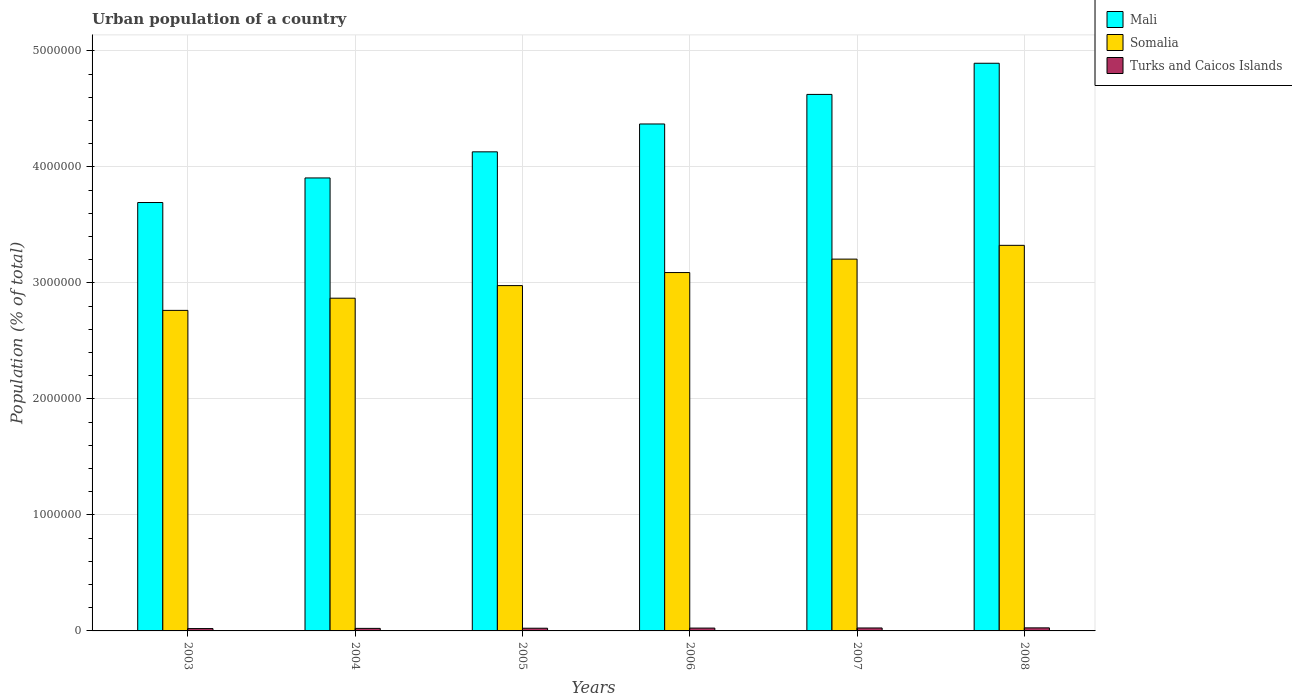How many different coloured bars are there?
Your answer should be very brief. 3. What is the urban population in Mali in 2007?
Offer a very short reply. 4.62e+06. Across all years, what is the maximum urban population in Mali?
Offer a terse response. 4.89e+06. Across all years, what is the minimum urban population in Mali?
Your answer should be very brief. 3.69e+06. In which year was the urban population in Turks and Caicos Islands maximum?
Give a very brief answer. 2008. What is the total urban population in Turks and Caicos Islands in the graph?
Ensure brevity in your answer.  1.41e+05. What is the difference between the urban population in Turks and Caicos Islands in 2003 and that in 2004?
Offer a very short reply. -1542. What is the difference between the urban population in Turks and Caicos Islands in 2003 and the urban population in Mali in 2005?
Your answer should be very brief. -4.11e+06. What is the average urban population in Turks and Caicos Islands per year?
Give a very brief answer. 2.36e+04. In the year 2005, what is the difference between the urban population in Turks and Caicos Islands and urban population in Mali?
Keep it short and to the point. -4.11e+06. In how many years, is the urban population in Turks and Caicos Islands greater than 1800000 %?
Make the answer very short. 0. What is the ratio of the urban population in Turks and Caicos Islands in 2003 to that in 2007?
Your answer should be compact. 0.8. Is the difference between the urban population in Turks and Caicos Islands in 2006 and 2007 greater than the difference between the urban population in Mali in 2006 and 2007?
Ensure brevity in your answer.  Yes. What is the difference between the highest and the second highest urban population in Turks and Caicos Islands?
Make the answer very short. 895. What is the difference between the highest and the lowest urban population in Somalia?
Ensure brevity in your answer.  5.61e+05. In how many years, is the urban population in Somalia greater than the average urban population in Somalia taken over all years?
Offer a terse response. 3. What does the 3rd bar from the left in 2004 represents?
Make the answer very short. Turks and Caicos Islands. What does the 1st bar from the right in 2004 represents?
Provide a succinct answer. Turks and Caicos Islands. Are all the bars in the graph horizontal?
Offer a very short reply. No. What is the difference between two consecutive major ticks on the Y-axis?
Your answer should be very brief. 1.00e+06. Does the graph contain grids?
Your answer should be very brief. Yes. How are the legend labels stacked?
Offer a very short reply. Vertical. What is the title of the graph?
Provide a succinct answer. Urban population of a country. What is the label or title of the X-axis?
Provide a short and direct response. Years. What is the label or title of the Y-axis?
Give a very brief answer. Population (% of total). What is the Population (% of total) of Mali in 2003?
Your answer should be very brief. 3.69e+06. What is the Population (% of total) of Somalia in 2003?
Offer a terse response. 2.76e+06. What is the Population (% of total) of Turks and Caicos Islands in 2003?
Your answer should be compact. 2.03e+04. What is the Population (% of total) in Mali in 2004?
Provide a short and direct response. 3.90e+06. What is the Population (% of total) of Somalia in 2004?
Offer a terse response. 2.87e+06. What is the Population (% of total) of Turks and Caicos Islands in 2004?
Offer a very short reply. 2.18e+04. What is the Population (% of total) in Mali in 2005?
Provide a succinct answer. 4.13e+06. What is the Population (% of total) in Somalia in 2005?
Offer a terse response. 2.98e+06. What is the Population (% of total) in Turks and Caicos Islands in 2005?
Offer a very short reply. 2.32e+04. What is the Population (% of total) of Mali in 2006?
Make the answer very short. 4.37e+06. What is the Population (% of total) in Somalia in 2006?
Offer a very short reply. 3.09e+06. What is the Population (% of total) in Turks and Caicos Islands in 2006?
Your response must be concise. 2.44e+04. What is the Population (% of total) in Mali in 2007?
Offer a terse response. 4.62e+06. What is the Population (% of total) of Somalia in 2007?
Ensure brevity in your answer.  3.20e+06. What is the Population (% of total) of Turks and Caicos Islands in 2007?
Your response must be concise. 2.54e+04. What is the Population (% of total) in Mali in 2008?
Your response must be concise. 4.89e+06. What is the Population (% of total) in Somalia in 2008?
Make the answer very short. 3.32e+06. What is the Population (% of total) of Turks and Caicos Islands in 2008?
Your answer should be very brief. 2.63e+04. Across all years, what is the maximum Population (% of total) of Mali?
Keep it short and to the point. 4.89e+06. Across all years, what is the maximum Population (% of total) in Somalia?
Provide a short and direct response. 3.32e+06. Across all years, what is the maximum Population (% of total) in Turks and Caicos Islands?
Provide a short and direct response. 2.63e+04. Across all years, what is the minimum Population (% of total) of Mali?
Offer a terse response. 3.69e+06. Across all years, what is the minimum Population (% of total) in Somalia?
Give a very brief answer. 2.76e+06. Across all years, what is the minimum Population (% of total) of Turks and Caicos Islands?
Provide a short and direct response. 2.03e+04. What is the total Population (% of total) of Mali in the graph?
Provide a short and direct response. 2.56e+07. What is the total Population (% of total) in Somalia in the graph?
Provide a succinct answer. 1.82e+07. What is the total Population (% of total) in Turks and Caicos Islands in the graph?
Offer a very short reply. 1.41e+05. What is the difference between the Population (% of total) in Mali in 2003 and that in 2004?
Your answer should be very brief. -2.12e+05. What is the difference between the Population (% of total) in Somalia in 2003 and that in 2004?
Make the answer very short. -1.05e+05. What is the difference between the Population (% of total) in Turks and Caicos Islands in 2003 and that in 2004?
Offer a very short reply. -1542. What is the difference between the Population (% of total) of Mali in 2003 and that in 2005?
Make the answer very short. -4.37e+05. What is the difference between the Population (% of total) in Somalia in 2003 and that in 2005?
Ensure brevity in your answer.  -2.14e+05. What is the difference between the Population (% of total) in Turks and Caicos Islands in 2003 and that in 2005?
Your response must be concise. -2932. What is the difference between the Population (% of total) in Mali in 2003 and that in 2006?
Your answer should be very brief. -6.77e+05. What is the difference between the Population (% of total) in Somalia in 2003 and that in 2006?
Ensure brevity in your answer.  -3.26e+05. What is the difference between the Population (% of total) of Turks and Caicos Islands in 2003 and that in 2006?
Give a very brief answer. -4126. What is the difference between the Population (% of total) of Mali in 2003 and that in 2007?
Your answer should be very brief. -9.32e+05. What is the difference between the Population (% of total) of Somalia in 2003 and that in 2007?
Make the answer very short. -4.42e+05. What is the difference between the Population (% of total) of Turks and Caicos Islands in 2003 and that in 2007?
Provide a short and direct response. -5153. What is the difference between the Population (% of total) of Mali in 2003 and that in 2008?
Provide a short and direct response. -1.20e+06. What is the difference between the Population (% of total) of Somalia in 2003 and that in 2008?
Make the answer very short. -5.61e+05. What is the difference between the Population (% of total) in Turks and Caicos Islands in 2003 and that in 2008?
Make the answer very short. -6048. What is the difference between the Population (% of total) of Mali in 2004 and that in 2005?
Offer a very short reply. -2.25e+05. What is the difference between the Population (% of total) of Somalia in 2004 and that in 2005?
Ensure brevity in your answer.  -1.09e+05. What is the difference between the Population (% of total) in Turks and Caicos Islands in 2004 and that in 2005?
Your response must be concise. -1390. What is the difference between the Population (% of total) in Mali in 2004 and that in 2006?
Offer a terse response. -4.65e+05. What is the difference between the Population (% of total) of Somalia in 2004 and that in 2006?
Your answer should be compact. -2.21e+05. What is the difference between the Population (% of total) of Turks and Caicos Islands in 2004 and that in 2006?
Ensure brevity in your answer.  -2584. What is the difference between the Population (% of total) of Mali in 2004 and that in 2007?
Make the answer very short. -7.20e+05. What is the difference between the Population (% of total) in Somalia in 2004 and that in 2007?
Your answer should be compact. -3.37e+05. What is the difference between the Population (% of total) of Turks and Caicos Islands in 2004 and that in 2007?
Give a very brief answer. -3611. What is the difference between the Population (% of total) of Mali in 2004 and that in 2008?
Make the answer very short. -9.89e+05. What is the difference between the Population (% of total) of Somalia in 2004 and that in 2008?
Your answer should be compact. -4.56e+05. What is the difference between the Population (% of total) of Turks and Caicos Islands in 2004 and that in 2008?
Your response must be concise. -4506. What is the difference between the Population (% of total) in Mali in 2005 and that in 2006?
Offer a terse response. -2.40e+05. What is the difference between the Population (% of total) of Somalia in 2005 and that in 2006?
Your answer should be very brief. -1.13e+05. What is the difference between the Population (% of total) in Turks and Caicos Islands in 2005 and that in 2006?
Make the answer very short. -1194. What is the difference between the Population (% of total) in Mali in 2005 and that in 2007?
Offer a very short reply. -4.95e+05. What is the difference between the Population (% of total) in Somalia in 2005 and that in 2007?
Offer a very short reply. -2.28e+05. What is the difference between the Population (% of total) of Turks and Caicos Islands in 2005 and that in 2007?
Provide a succinct answer. -2221. What is the difference between the Population (% of total) in Mali in 2005 and that in 2008?
Ensure brevity in your answer.  -7.64e+05. What is the difference between the Population (% of total) of Somalia in 2005 and that in 2008?
Your answer should be very brief. -3.47e+05. What is the difference between the Population (% of total) in Turks and Caicos Islands in 2005 and that in 2008?
Offer a terse response. -3116. What is the difference between the Population (% of total) in Mali in 2006 and that in 2007?
Provide a short and direct response. -2.55e+05. What is the difference between the Population (% of total) in Somalia in 2006 and that in 2007?
Your answer should be very brief. -1.16e+05. What is the difference between the Population (% of total) of Turks and Caicos Islands in 2006 and that in 2007?
Make the answer very short. -1027. What is the difference between the Population (% of total) of Mali in 2006 and that in 2008?
Keep it short and to the point. -5.23e+05. What is the difference between the Population (% of total) in Somalia in 2006 and that in 2008?
Provide a short and direct response. -2.35e+05. What is the difference between the Population (% of total) of Turks and Caicos Islands in 2006 and that in 2008?
Provide a succinct answer. -1922. What is the difference between the Population (% of total) in Mali in 2007 and that in 2008?
Provide a succinct answer. -2.69e+05. What is the difference between the Population (% of total) of Somalia in 2007 and that in 2008?
Make the answer very short. -1.19e+05. What is the difference between the Population (% of total) of Turks and Caicos Islands in 2007 and that in 2008?
Give a very brief answer. -895. What is the difference between the Population (% of total) of Mali in 2003 and the Population (% of total) of Somalia in 2004?
Give a very brief answer. 8.25e+05. What is the difference between the Population (% of total) of Mali in 2003 and the Population (% of total) of Turks and Caicos Islands in 2004?
Give a very brief answer. 3.67e+06. What is the difference between the Population (% of total) in Somalia in 2003 and the Population (% of total) in Turks and Caicos Islands in 2004?
Your answer should be compact. 2.74e+06. What is the difference between the Population (% of total) in Mali in 2003 and the Population (% of total) in Somalia in 2005?
Your answer should be very brief. 7.16e+05. What is the difference between the Population (% of total) of Mali in 2003 and the Population (% of total) of Turks and Caicos Islands in 2005?
Provide a succinct answer. 3.67e+06. What is the difference between the Population (% of total) in Somalia in 2003 and the Population (% of total) in Turks and Caicos Islands in 2005?
Provide a short and direct response. 2.74e+06. What is the difference between the Population (% of total) of Mali in 2003 and the Population (% of total) of Somalia in 2006?
Provide a short and direct response. 6.04e+05. What is the difference between the Population (% of total) of Mali in 2003 and the Population (% of total) of Turks and Caicos Islands in 2006?
Offer a terse response. 3.67e+06. What is the difference between the Population (% of total) of Somalia in 2003 and the Population (% of total) of Turks and Caicos Islands in 2006?
Your response must be concise. 2.74e+06. What is the difference between the Population (% of total) in Mali in 2003 and the Population (% of total) in Somalia in 2007?
Ensure brevity in your answer.  4.88e+05. What is the difference between the Population (% of total) of Mali in 2003 and the Population (% of total) of Turks and Caicos Islands in 2007?
Offer a very short reply. 3.67e+06. What is the difference between the Population (% of total) of Somalia in 2003 and the Population (% of total) of Turks and Caicos Islands in 2007?
Offer a very short reply. 2.74e+06. What is the difference between the Population (% of total) in Mali in 2003 and the Population (% of total) in Somalia in 2008?
Provide a short and direct response. 3.69e+05. What is the difference between the Population (% of total) in Mali in 2003 and the Population (% of total) in Turks and Caicos Islands in 2008?
Keep it short and to the point. 3.67e+06. What is the difference between the Population (% of total) in Somalia in 2003 and the Population (% of total) in Turks and Caicos Islands in 2008?
Keep it short and to the point. 2.74e+06. What is the difference between the Population (% of total) of Mali in 2004 and the Population (% of total) of Somalia in 2005?
Offer a very short reply. 9.28e+05. What is the difference between the Population (% of total) in Mali in 2004 and the Population (% of total) in Turks and Caicos Islands in 2005?
Your answer should be very brief. 3.88e+06. What is the difference between the Population (% of total) in Somalia in 2004 and the Population (% of total) in Turks and Caicos Islands in 2005?
Give a very brief answer. 2.84e+06. What is the difference between the Population (% of total) of Mali in 2004 and the Population (% of total) of Somalia in 2006?
Your answer should be compact. 8.15e+05. What is the difference between the Population (% of total) of Mali in 2004 and the Population (% of total) of Turks and Caicos Islands in 2006?
Provide a short and direct response. 3.88e+06. What is the difference between the Population (% of total) in Somalia in 2004 and the Population (% of total) in Turks and Caicos Islands in 2006?
Your answer should be compact. 2.84e+06. What is the difference between the Population (% of total) of Mali in 2004 and the Population (% of total) of Somalia in 2007?
Keep it short and to the point. 7.00e+05. What is the difference between the Population (% of total) of Mali in 2004 and the Population (% of total) of Turks and Caicos Islands in 2007?
Your answer should be very brief. 3.88e+06. What is the difference between the Population (% of total) of Somalia in 2004 and the Population (% of total) of Turks and Caicos Islands in 2007?
Make the answer very short. 2.84e+06. What is the difference between the Population (% of total) in Mali in 2004 and the Population (% of total) in Somalia in 2008?
Make the answer very short. 5.81e+05. What is the difference between the Population (% of total) of Mali in 2004 and the Population (% of total) of Turks and Caicos Islands in 2008?
Your response must be concise. 3.88e+06. What is the difference between the Population (% of total) of Somalia in 2004 and the Population (% of total) of Turks and Caicos Islands in 2008?
Your answer should be compact. 2.84e+06. What is the difference between the Population (% of total) of Mali in 2005 and the Population (% of total) of Somalia in 2006?
Keep it short and to the point. 1.04e+06. What is the difference between the Population (% of total) in Mali in 2005 and the Population (% of total) in Turks and Caicos Islands in 2006?
Ensure brevity in your answer.  4.11e+06. What is the difference between the Population (% of total) of Somalia in 2005 and the Population (% of total) of Turks and Caicos Islands in 2006?
Keep it short and to the point. 2.95e+06. What is the difference between the Population (% of total) of Mali in 2005 and the Population (% of total) of Somalia in 2007?
Make the answer very short. 9.25e+05. What is the difference between the Population (% of total) in Mali in 2005 and the Population (% of total) in Turks and Caicos Islands in 2007?
Ensure brevity in your answer.  4.10e+06. What is the difference between the Population (% of total) of Somalia in 2005 and the Population (% of total) of Turks and Caicos Islands in 2007?
Offer a very short reply. 2.95e+06. What is the difference between the Population (% of total) in Mali in 2005 and the Population (% of total) in Somalia in 2008?
Give a very brief answer. 8.06e+05. What is the difference between the Population (% of total) in Mali in 2005 and the Population (% of total) in Turks and Caicos Islands in 2008?
Your response must be concise. 4.10e+06. What is the difference between the Population (% of total) of Somalia in 2005 and the Population (% of total) of Turks and Caicos Islands in 2008?
Your response must be concise. 2.95e+06. What is the difference between the Population (% of total) in Mali in 2006 and the Population (% of total) in Somalia in 2007?
Your answer should be compact. 1.16e+06. What is the difference between the Population (% of total) in Mali in 2006 and the Population (% of total) in Turks and Caicos Islands in 2007?
Offer a very short reply. 4.34e+06. What is the difference between the Population (% of total) in Somalia in 2006 and the Population (% of total) in Turks and Caicos Islands in 2007?
Your response must be concise. 3.06e+06. What is the difference between the Population (% of total) in Mali in 2006 and the Population (% of total) in Somalia in 2008?
Offer a terse response. 1.05e+06. What is the difference between the Population (% of total) of Mali in 2006 and the Population (% of total) of Turks and Caicos Islands in 2008?
Make the answer very short. 4.34e+06. What is the difference between the Population (% of total) of Somalia in 2006 and the Population (% of total) of Turks and Caicos Islands in 2008?
Provide a short and direct response. 3.06e+06. What is the difference between the Population (% of total) in Mali in 2007 and the Population (% of total) in Somalia in 2008?
Offer a very short reply. 1.30e+06. What is the difference between the Population (% of total) of Mali in 2007 and the Population (% of total) of Turks and Caicos Islands in 2008?
Offer a very short reply. 4.60e+06. What is the difference between the Population (% of total) in Somalia in 2007 and the Population (% of total) in Turks and Caicos Islands in 2008?
Offer a terse response. 3.18e+06. What is the average Population (% of total) in Mali per year?
Keep it short and to the point. 4.27e+06. What is the average Population (% of total) in Somalia per year?
Provide a short and direct response. 3.04e+06. What is the average Population (% of total) in Turks and Caicos Islands per year?
Keep it short and to the point. 2.36e+04. In the year 2003, what is the difference between the Population (% of total) of Mali and Population (% of total) of Somalia?
Make the answer very short. 9.30e+05. In the year 2003, what is the difference between the Population (% of total) in Mali and Population (% of total) in Turks and Caicos Islands?
Your answer should be very brief. 3.67e+06. In the year 2003, what is the difference between the Population (% of total) of Somalia and Population (% of total) of Turks and Caicos Islands?
Give a very brief answer. 2.74e+06. In the year 2004, what is the difference between the Population (% of total) of Mali and Population (% of total) of Somalia?
Your answer should be compact. 1.04e+06. In the year 2004, what is the difference between the Population (% of total) in Mali and Population (% of total) in Turks and Caicos Islands?
Provide a short and direct response. 3.88e+06. In the year 2004, what is the difference between the Population (% of total) in Somalia and Population (% of total) in Turks and Caicos Islands?
Your answer should be compact. 2.85e+06. In the year 2005, what is the difference between the Population (% of total) in Mali and Population (% of total) in Somalia?
Keep it short and to the point. 1.15e+06. In the year 2005, what is the difference between the Population (% of total) in Mali and Population (% of total) in Turks and Caicos Islands?
Your answer should be compact. 4.11e+06. In the year 2005, what is the difference between the Population (% of total) of Somalia and Population (% of total) of Turks and Caicos Islands?
Provide a succinct answer. 2.95e+06. In the year 2006, what is the difference between the Population (% of total) in Mali and Population (% of total) in Somalia?
Offer a terse response. 1.28e+06. In the year 2006, what is the difference between the Population (% of total) of Mali and Population (% of total) of Turks and Caicos Islands?
Your answer should be compact. 4.35e+06. In the year 2006, what is the difference between the Population (% of total) of Somalia and Population (% of total) of Turks and Caicos Islands?
Your answer should be compact. 3.06e+06. In the year 2007, what is the difference between the Population (% of total) of Mali and Population (% of total) of Somalia?
Make the answer very short. 1.42e+06. In the year 2007, what is the difference between the Population (% of total) in Mali and Population (% of total) in Turks and Caicos Islands?
Your response must be concise. 4.60e+06. In the year 2007, what is the difference between the Population (% of total) of Somalia and Population (% of total) of Turks and Caicos Islands?
Give a very brief answer. 3.18e+06. In the year 2008, what is the difference between the Population (% of total) in Mali and Population (% of total) in Somalia?
Ensure brevity in your answer.  1.57e+06. In the year 2008, what is the difference between the Population (% of total) of Mali and Population (% of total) of Turks and Caicos Islands?
Offer a very short reply. 4.87e+06. In the year 2008, what is the difference between the Population (% of total) of Somalia and Population (% of total) of Turks and Caicos Islands?
Provide a succinct answer. 3.30e+06. What is the ratio of the Population (% of total) in Mali in 2003 to that in 2004?
Ensure brevity in your answer.  0.95. What is the ratio of the Population (% of total) of Somalia in 2003 to that in 2004?
Give a very brief answer. 0.96. What is the ratio of the Population (% of total) of Turks and Caicos Islands in 2003 to that in 2004?
Give a very brief answer. 0.93. What is the ratio of the Population (% of total) in Mali in 2003 to that in 2005?
Offer a terse response. 0.89. What is the ratio of the Population (% of total) of Somalia in 2003 to that in 2005?
Give a very brief answer. 0.93. What is the ratio of the Population (% of total) in Turks and Caicos Islands in 2003 to that in 2005?
Keep it short and to the point. 0.87. What is the ratio of the Population (% of total) in Mali in 2003 to that in 2006?
Provide a short and direct response. 0.84. What is the ratio of the Population (% of total) in Somalia in 2003 to that in 2006?
Provide a short and direct response. 0.89. What is the ratio of the Population (% of total) in Turks and Caicos Islands in 2003 to that in 2006?
Your response must be concise. 0.83. What is the ratio of the Population (% of total) of Mali in 2003 to that in 2007?
Ensure brevity in your answer.  0.8. What is the ratio of the Population (% of total) of Somalia in 2003 to that in 2007?
Ensure brevity in your answer.  0.86. What is the ratio of the Population (% of total) in Turks and Caicos Islands in 2003 to that in 2007?
Make the answer very short. 0.8. What is the ratio of the Population (% of total) in Mali in 2003 to that in 2008?
Make the answer very short. 0.75. What is the ratio of the Population (% of total) in Somalia in 2003 to that in 2008?
Offer a terse response. 0.83. What is the ratio of the Population (% of total) in Turks and Caicos Islands in 2003 to that in 2008?
Provide a short and direct response. 0.77. What is the ratio of the Population (% of total) of Mali in 2004 to that in 2005?
Your answer should be very brief. 0.95. What is the ratio of the Population (% of total) of Somalia in 2004 to that in 2005?
Offer a very short reply. 0.96. What is the ratio of the Population (% of total) of Turks and Caicos Islands in 2004 to that in 2005?
Offer a very short reply. 0.94. What is the ratio of the Population (% of total) of Mali in 2004 to that in 2006?
Offer a terse response. 0.89. What is the ratio of the Population (% of total) of Somalia in 2004 to that in 2006?
Give a very brief answer. 0.93. What is the ratio of the Population (% of total) of Turks and Caicos Islands in 2004 to that in 2006?
Your answer should be compact. 0.89. What is the ratio of the Population (% of total) in Mali in 2004 to that in 2007?
Your response must be concise. 0.84. What is the ratio of the Population (% of total) in Somalia in 2004 to that in 2007?
Give a very brief answer. 0.89. What is the ratio of the Population (% of total) in Turks and Caicos Islands in 2004 to that in 2007?
Offer a terse response. 0.86. What is the ratio of the Population (% of total) of Mali in 2004 to that in 2008?
Offer a terse response. 0.8. What is the ratio of the Population (% of total) of Somalia in 2004 to that in 2008?
Your response must be concise. 0.86. What is the ratio of the Population (% of total) of Turks and Caicos Islands in 2004 to that in 2008?
Make the answer very short. 0.83. What is the ratio of the Population (% of total) in Mali in 2005 to that in 2006?
Make the answer very short. 0.94. What is the ratio of the Population (% of total) of Somalia in 2005 to that in 2006?
Offer a very short reply. 0.96. What is the ratio of the Population (% of total) in Turks and Caicos Islands in 2005 to that in 2006?
Provide a succinct answer. 0.95. What is the ratio of the Population (% of total) of Mali in 2005 to that in 2007?
Offer a very short reply. 0.89. What is the ratio of the Population (% of total) in Somalia in 2005 to that in 2007?
Your response must be concise. 0.93. What is the ratio of the Population (% of total) of Turks and Caicos Islands in 2005 to that in 2007?
Provide a short and direct response. 0.91. What is the ratio of the Population (% of total) in Mali in 2005 to that in 2008?
Ensure brevity in your answer.  0.84. What is the ratio of the Population (% of total) in Somalia in 2005 to that in 2008?
Provide a short and direct response. 0.9. What is the ratio of the Population (% of total) of Turks and Caicos Islands in 2005 to that in 2008?
Make the answer very short. 0.88. What is the ratio of the Population (% of total) in Mali in 2006 to that in 2007?
Give a very brief answer. 0.94. What is the ratio of the Population (% of total) in Somalia in 2006 to that in 2007?
Offer a very short reply. 0.96. What is the ratio of the Population (% of total) in Turks and Caicos Islands in 2006 to that in 2007?
Your response must be concise. 0.96. What is the ratio of the Population (% of total) of Mali in 2006 to that in 2008?
Your response must be concise. 0.89. What is the ratio of the Population (% of total) in Somalia in 2006 to that in 2008?
Keep it short and to the point. 0.93. What is the ratio of the Population (% of total) in Turks and Caicos Islands in 2006 to that in 2008?
Ensure brevity in your answer.  0.93. What is the ratio of the Population (% of total) in Mali in 2007 to that in 2008?
Your answer should be very brief. 0.95. What is the difference between the highest and the second highest Population (% of total) in Mali?
Keep it short and to the point. 2.69e+05. What is the difference between the highest and the second highest Population (% of total) in Somalia?
Your response must be concise. 1.19e+05. What is the difference between the highest and the second highest Population (% of total) of Turks and Caicos Islands?
Offer a terse response. 895. What is the difference between the highest and the lowest Population (% of total) of Mali?
Offer a very short reply. 1.20e+06. What is the difference between the highest and the lowest Population (% of total) of Somalia?
Ensure brevity in your answer.  5.61e+05. What is the difference between the highest and the lowest Population (% of total) in Turks and Caicos Islands?
Offer a very short reply. 6048. 